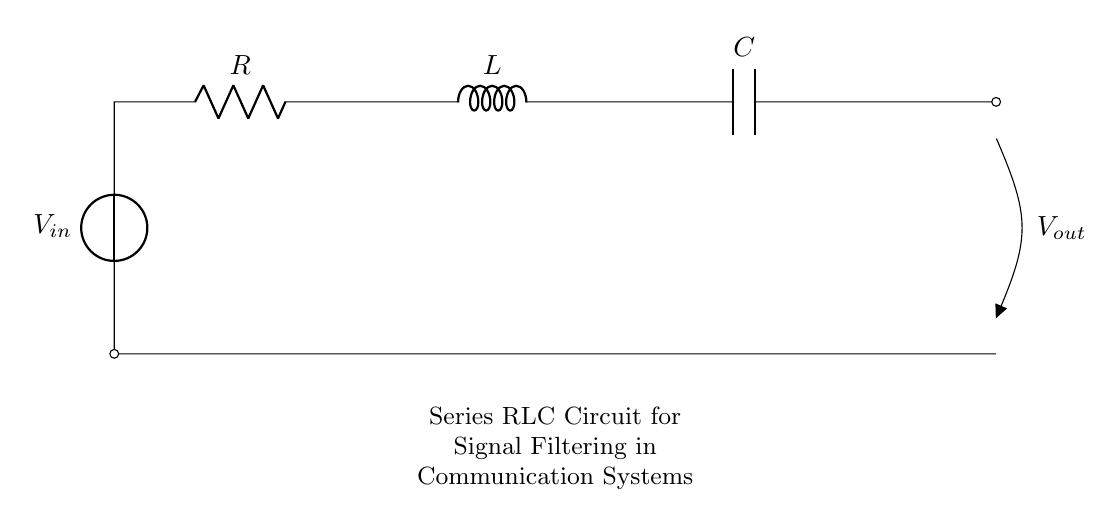What components are in this circuit? The circuit contains a voltage source, resistor, inductor, and capacitor. These components are arranged in series, as indicated by their connections from the voltage source to the output.
Answer: voltage source, resistor, inductor, capacitor What is the order of the components from input to output? The order of the components is: voltage source first, then the resistor, followed by the inductor, and finally the capacitor before the output. This sequence is determined by tracing the connection line from the input to the output.
Answer: voltage source, resistor, inductor, capacitor What is the purpose of the series RLC circuit? The purpose of the series RLC circuit is to filter specific frequencies of signals, which is critical in communication systems for reducing noise and improving signal clarity. This filtering comes from the behavior of the resistor, inductor, and capacitor when combined in a series configuration.
Answer: filtering signals How many components are active in series between the input and output? There are three active components (R, L, and C) placed in series between the input and output, which means the current flows through all of them sequentially.
Answer: three What is the effect of increasing the resistance in the circuit? Increasing the resistance will decrease the overall current flowing through the circuit since current is inversely related to resistance in Ohm's law. Additionally, it can also affect the damping of oscillations in the circuit, leading to less pronounced resonant behavior.
Answer: decreases current What is the resonant frequency of the series RLC circuit? The resonant frequency, expressed in hertz, is calculated using the formula 1 divided by the square root of the product of L and C, where L is inductance and C is capacitance. This frequency is where the circuit will naturally oscillate with maximum amplitude.
Answer: 1/√(LC) What happens to the output voltage when resonance occurs? When resonance occurs, the output voltage reaches its maximum possible amplitude, resulting in considerable signal amplification at the resonant frequency. This indicates that the circuit is effectively allowing that frequency to pass while attenuating others.
Answer: maximum output voltage 